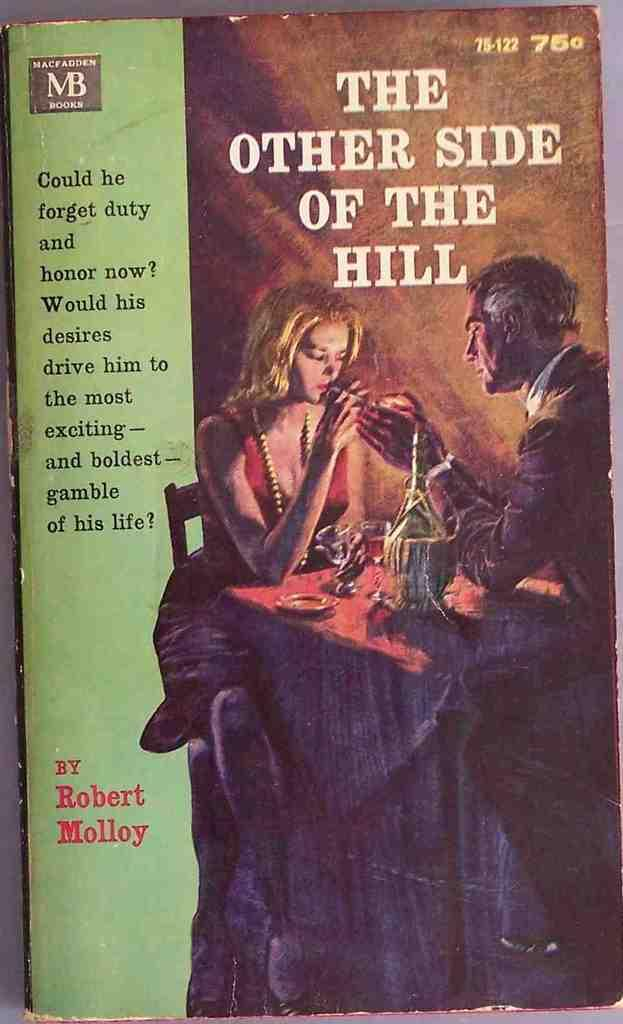<image>
Write a terse but informative summary of the picture. The other side of the Hill book has a man and a lady on the front 